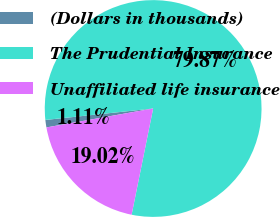<chart> <loc_0><loc_0><loc_500><loc_500><pie_chart><fcel>(Dollars in thousands)<fcel>The Prudential Insurance<fcel>Unaffiliated life insurance<nl><fcel>1.11%<fcel>79.86%<fcel>19.02%<nl></chart> 